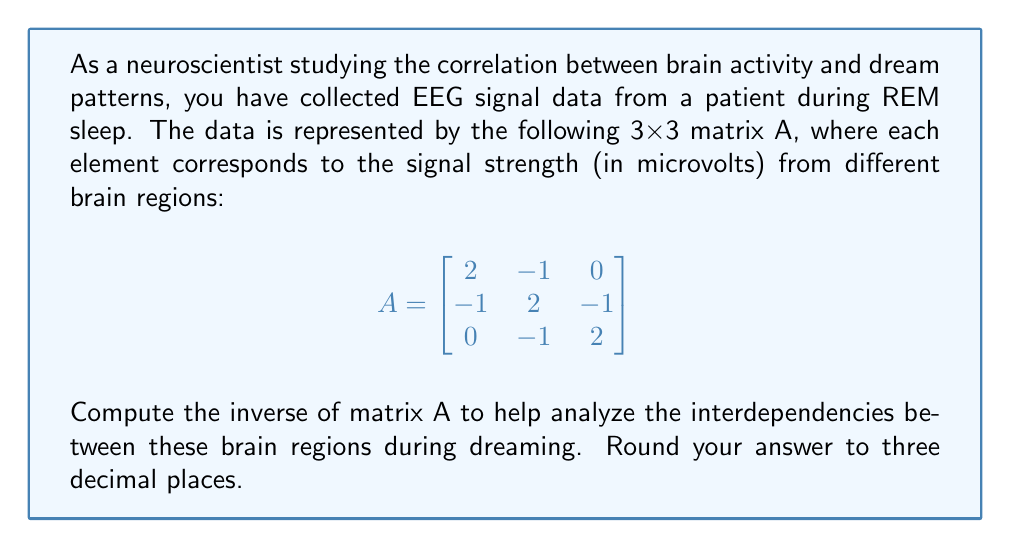Help me with this question. To find the inverse of matrix A, we'll follow these steps:

1) First, we need to calculate the determinant of A:
   $det(A) = 2(2(2) - (-1)(-1)) - (-1)((-1)(2) - 0(-1)) + 0$
   $det(A) = 2(4-1) - (-1)(-2) = 2(3) - 2 = 4$

2) Now, we'll find the matrix of cofactors. For each element $a_{ij}$, we calculate $(-1)^{i+j} \times$ the determinant of the 2x2 matrix formed by removing row i and column j:

   $C_{11} = (-1)^{1+1}(2(2)-(-1)(-1)) = 3$
   $C_{12} = (-1)^{1+2}((-1)(2)-0(-1)) = 2$
   $C_{13} = (-1)^{1+3}((-1)(-1)-(-1)(0)) = -1$
   $C_{21} = (-1)^{2+1}((-1)(2)-0(2)) = 2$
   $C_{22} = (-1)^{2+2}(2(2)-0(0)) = 4$
   $C_{23} = (-1)^{2+3}(2(0)-(-1)(-1)) = -2$
   $C_{31} = (-1)^{3+1}((-1)(-1)-(-1)(2)) = -1$
   $C_{32} = (-1)^{3+2}(2(-1)-(-1)(2)) = -2$
   $C_{33} = (-1)^{3+3}(2(2)-(-1)(-1)) = 3$

3) The adjugate matrix is the transpose of the cofactor matrix:

   $$ adj(A) = \begin{bmatrix}
   3 & 2 & -1 \\
   2 & 4 & -2 \\
   -1 & -2 & 3
   \end{bmatrix} $$

4) The inverse of A is given by $A^{-1} = \frac{1}{det(A)} \times adj(A)$:

   $$ A^{-1} = \frac{1}{4} \begin{bmatrix}
   3 & 2 & -1 \\
   2 & 4 & -2 \\
   -1 & -2 & 3
   \end{bmatrix} $$

5) Simplifying and rounding to three decimal places:

   $$ A^{-1} = \begin{bmatrix}
   0.750 & 0.500 & -0.250 \\
   0.500 & 1.000 & -0.500 \\
   -0.250 & -0.500 & 0.750
   \end{bmatrix} $$
Answer: $$ A^{-1} = \begin{bmatrix}
0.750 & 0.500 & -0.250 \\
0.500 & 1.000 & -0.500 \\
-0.250 & -0.500 & 0.750
\end{bmatrix} $$ 